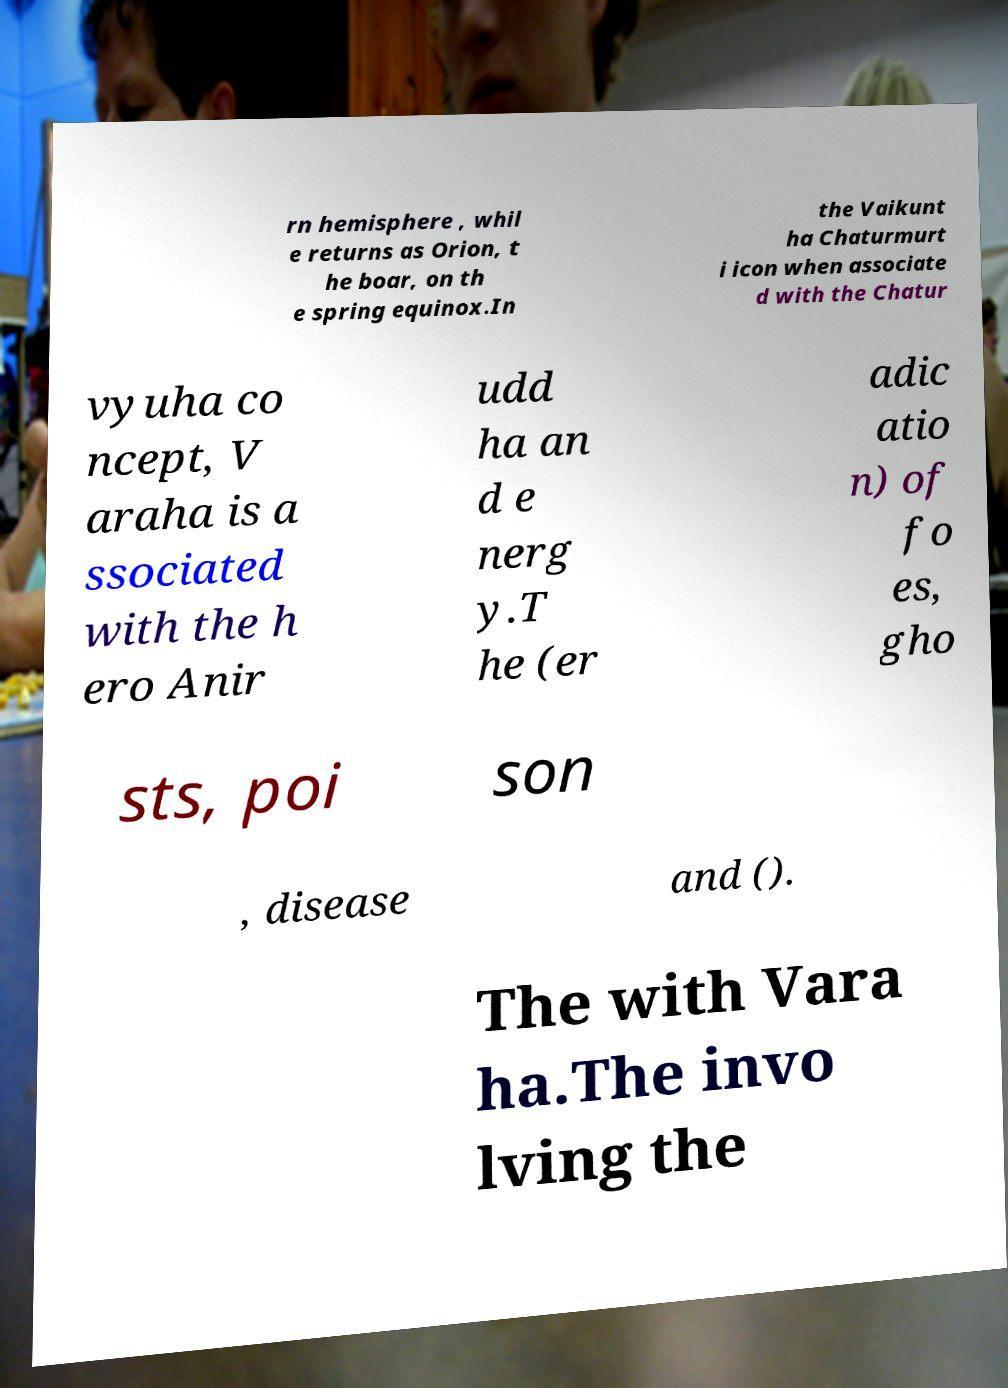Please identify and transcribe the text found in this image. rn hemisphere , whil e returns as Orion, t he boar, on th e spring equinox.In the Vaikunt ha Chaturmurt i icon when associate d with the Chatur vyuha co ncept, V araha is a ssociated with the h ero Anir udd ha an d e nerg y.T he (er adic atio n) of fo es, gho sts, poi son , disease and (). The with Vara ha.The invo lving the 